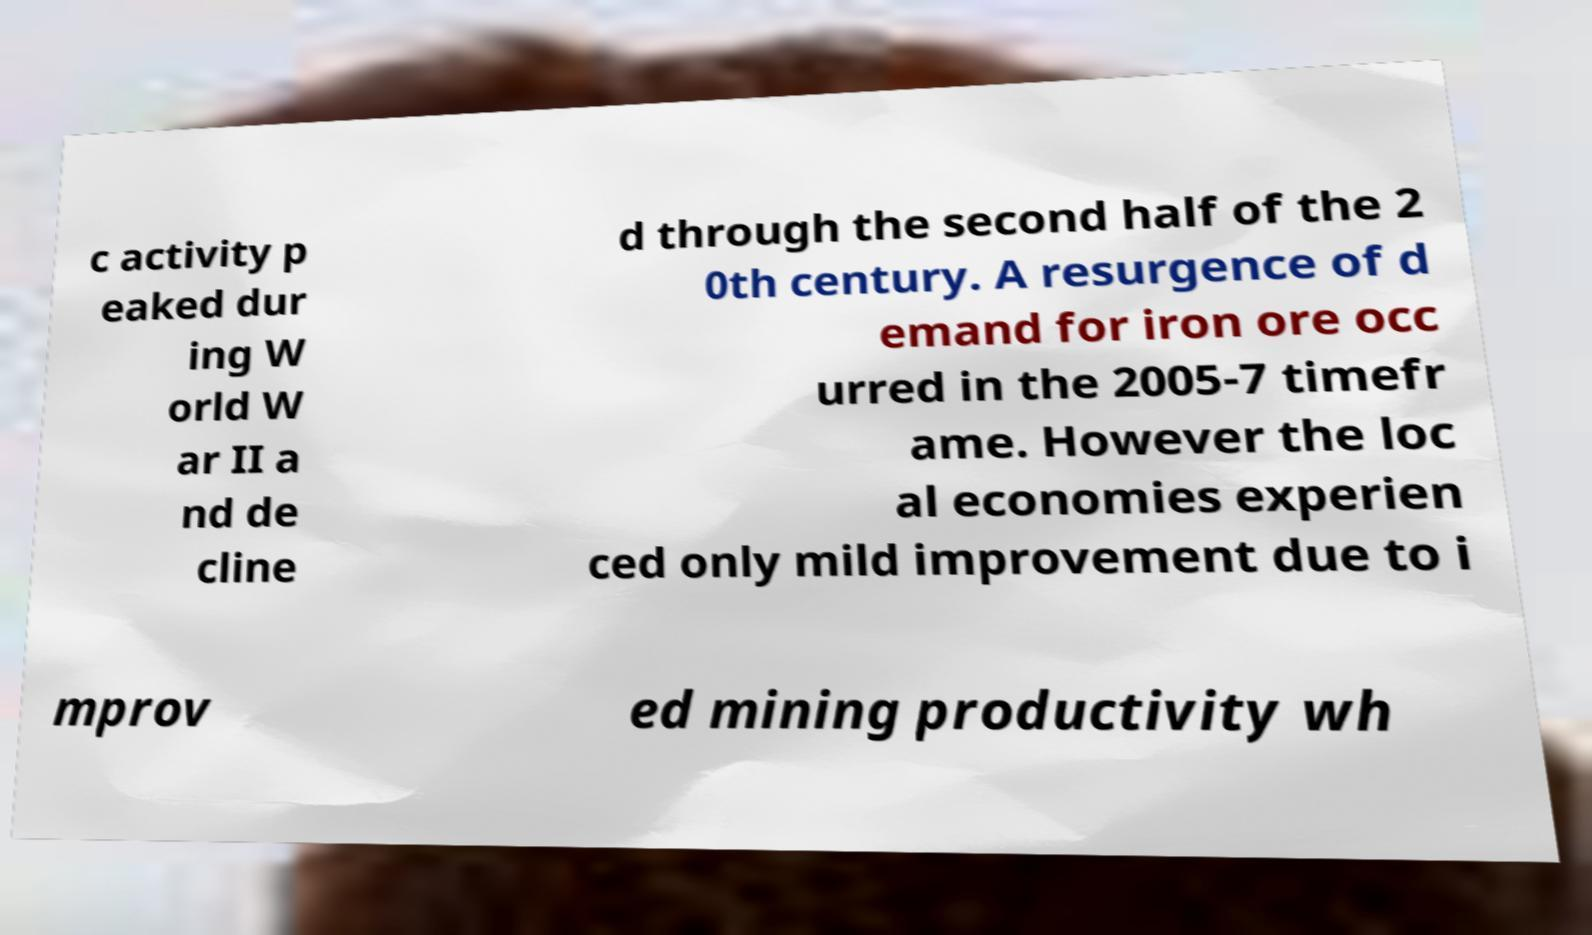Could you extract and type out the text from this image? c activity p eaked dur ing W orld W ar II a nd de cline d through the second half of the 2 0th century. A resurgence of d emand for iron ore occ urred in the 2005-7 timefr ame. However the loc al economies experien ced only mild improvement due to i mprov ed mining productivity wh 